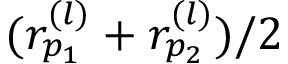Convert formula to latex. <formula><loc_0><loc_0><loc_500><loc_500>( r _ { p _ { 1 } } ^ { ( l ) } + r _ { p _ { 2 } } ^ { ( l ) } ) / 2</formula> 